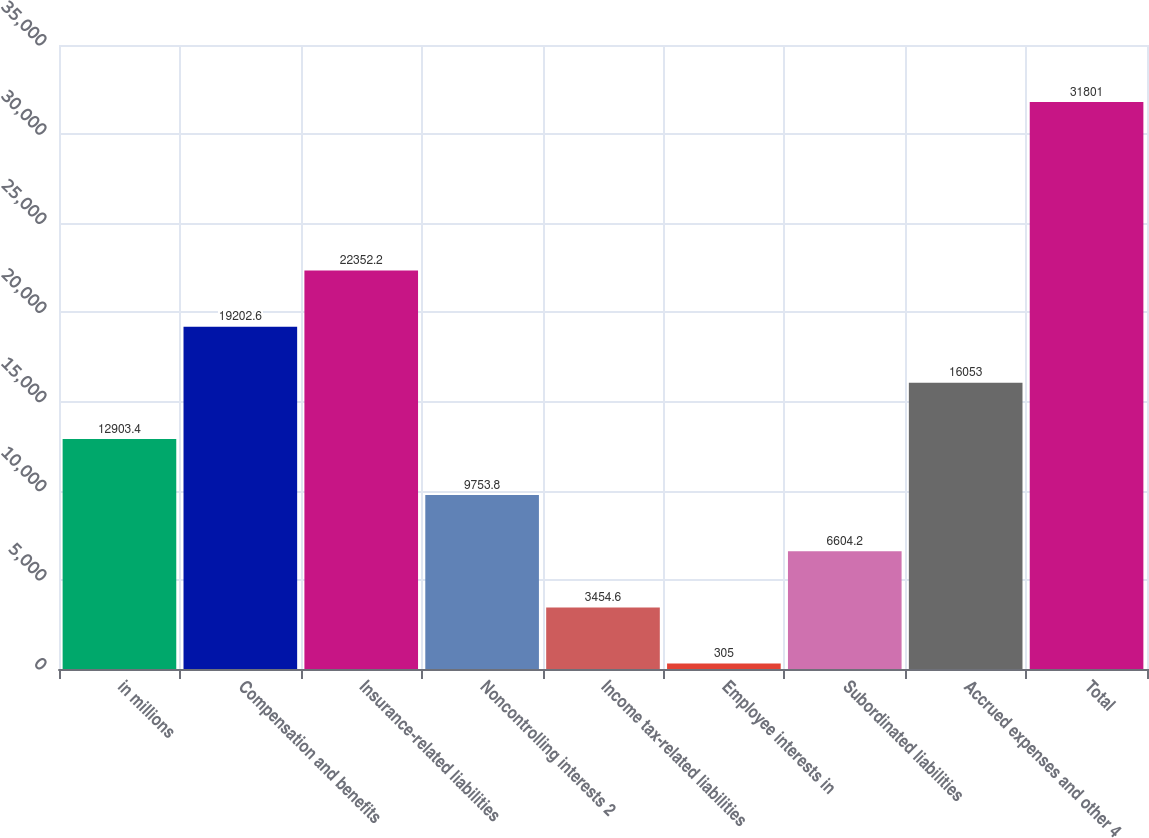<chart> <loc_0><loc_0><loc_500><loc_500><bar_chart><fcel>in millions<fcel>Compensation and benefits<fcel>Insurance-related liabilities<fcel>Noncontrolling interests 2<fcel>Income tax-related liabilities<fcel>Employee interests in<fcel>Subordinated liabilities<fcel>Accrued expenses and other 4<fcel>Total<nl><fcel>12903.4<fcel>19202.6<fcel>22352.2<fcel>9753.8<fcel>3454.6<fcel>305<fcel>6604.2<fcel>16053<fcel>31801<nl></chart> 